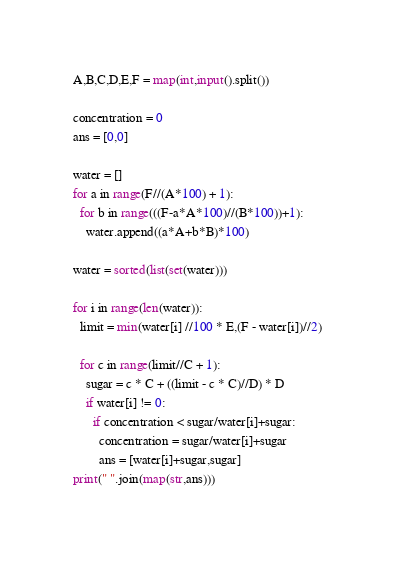<code> <loc_0><loc_0><loc_500><loc_500><_Python_>A,B,C,D,E,F = map(int,input().split())

concentration = 0
ans = [0,0]

water = []
for a in range(F//(A*100) + 1):
  for b in range(((F-a*A*100)//(B*100))+1):
    water.append((a*A+b*B)*100)
    
water = sorted(list(set(water)))

for i in range(len(water)):
  limit = min(water[i] //100 * E,(F - water[i])//2)
  
  for c in range(limit//C + 1):
    sugar = c * C + ((limit - c * C)//D) * D
    if water[i] != 0:
      if concentration < sugar/water[i]+sugar:
        concentration = sugar/water[i]+sugar
        ans = [water[i]+sugar,sugar]
print(" ".join(map(str,ans)))</code> 